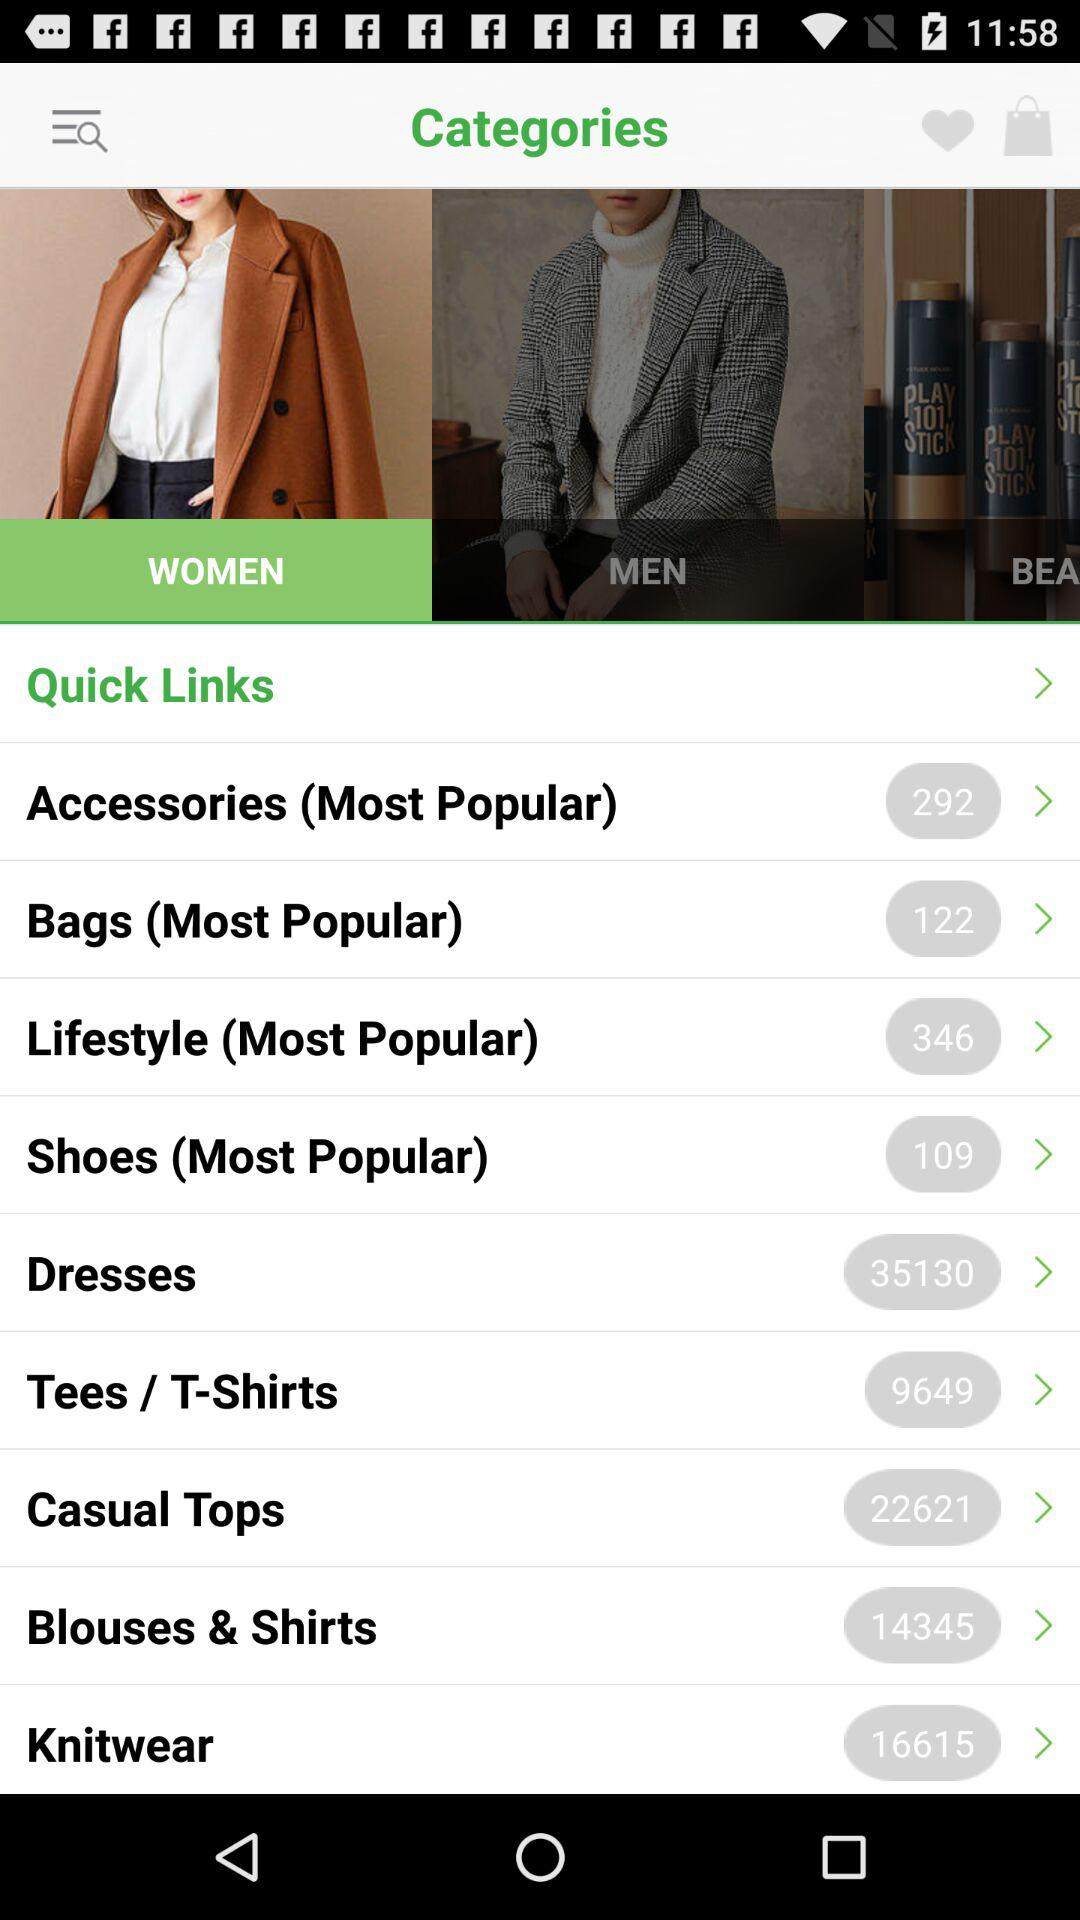What size does the user wear?
When the provided information is insufficient, respond with <no answer>. <no answer> 